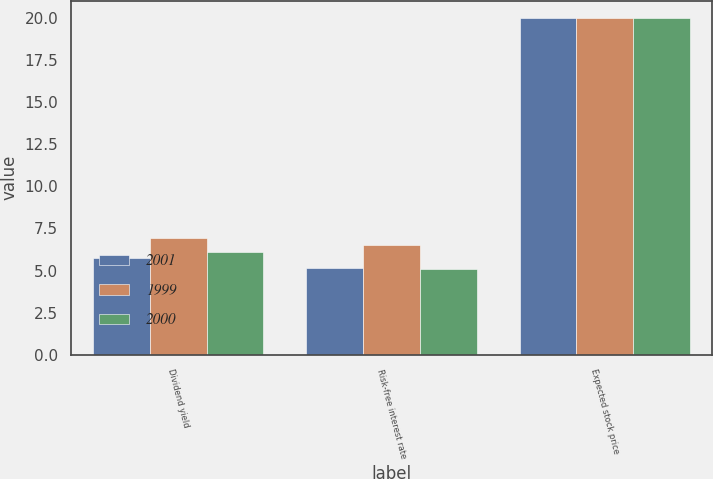<chart> <loc_0><loc_0><loc_500><loc_500><stacked_bar_chart><ecel><fcel>Dividend yield<fcel>Risk-free interest rate<fcel>Expected stock price<nl><fcel>2001<fcel>5.72<fcel>5.13<fcel>20<nl><fcel>1999<fcel>6.9<fcel>6.51<fcel>20<nl><fcel>2000<fcel>6.08<fcel>5.07<fcel>20<nl></chart> 